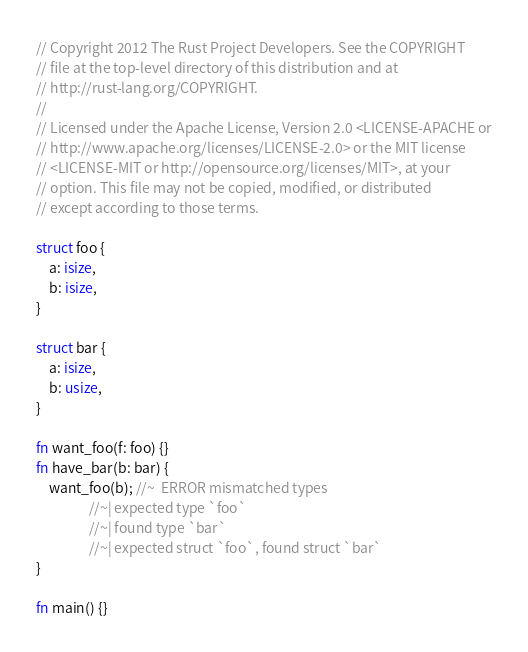<code> <loc_0><loc_0><loc_500><loc_500><_Rust_>// Copyright 2012 The Rust Project Developers. See the COPYRIGHT
// file at the top-level directory of this distribution and at
// http://rust-lang.org/COPYRIGHT.
//
// Licensed under the Apache License, Version 2.0 <LICENSE-APACHE or
// http://www.apache.org/licenses/LICENSE-2.0> or the MIT license
// <LICENSE-MIT or http://opensource.org/licenses/MIT>, at your
// option. This file may not be copied, modified, or distributed
// except according to those terms.

struct foo {
    a: isize,
    b: isize,
}

struct bar {
    a: isize,
    b: usize,
}

fn want_foo(f: foo) {}
fn have_bar(b: bar) {
    want_foo(b); //~  ERROR mismatched types
                 //~| expected type `foo`
                 //~| found type `bar`
                 //~| expected struct `foo`, found struct `bar`
}

fn main() {}
</code> 